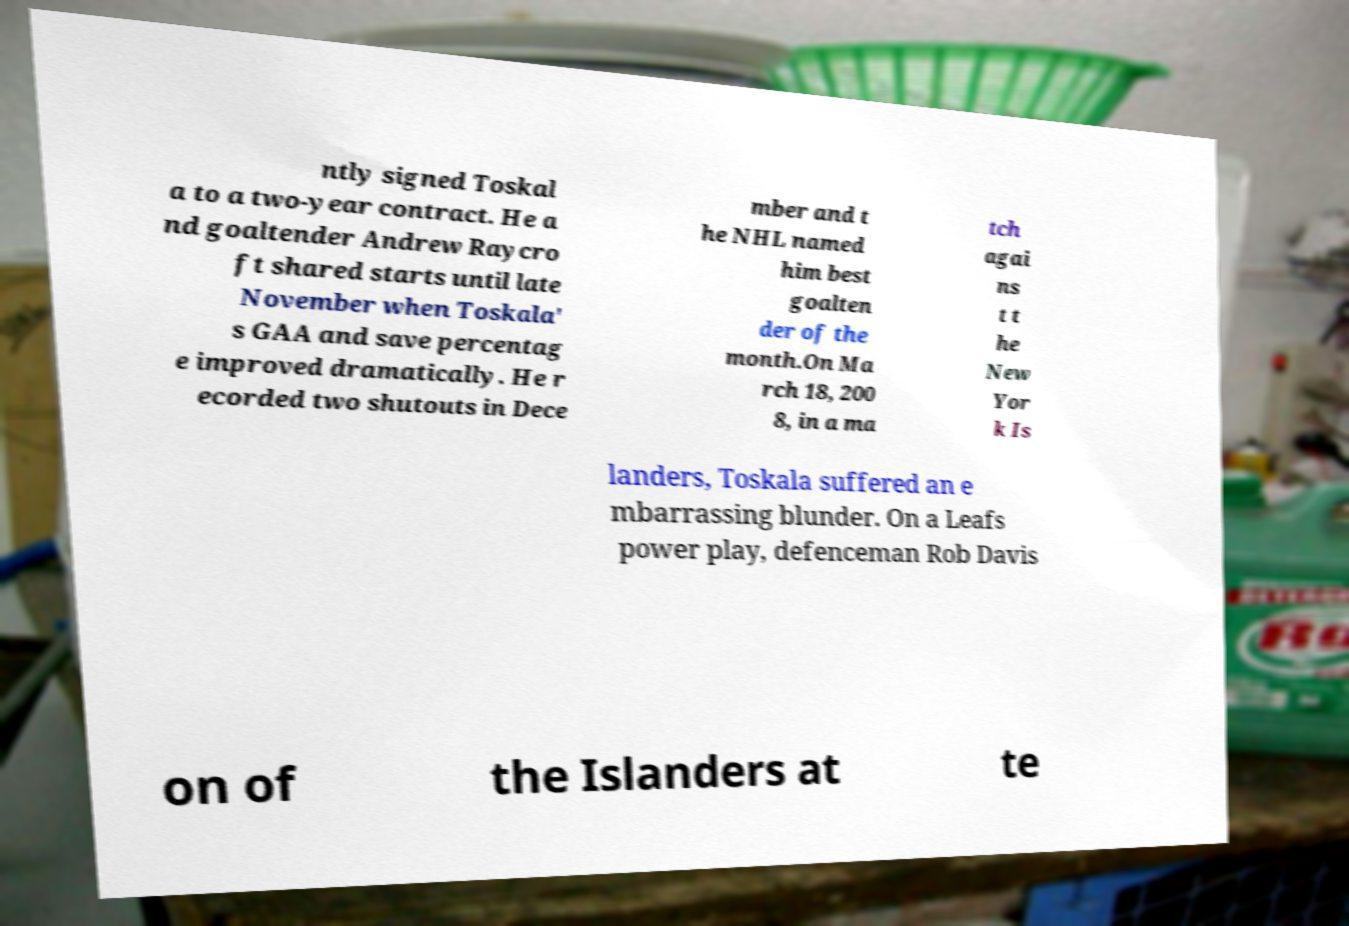Please identify and transcribe the text found in this image. ntly signed Toskal a to a two-year contract. He a nd goaltender Andrew Raycro ft shared starts until late November when Toskala' s GAA and save percentag e improved dramatically. He r ecorded two shutouts in Dece mber and t he NHL named him best goalten der of the month.On Ma rch 18, 200 8, in a ma tch agai ns t t he New Yor k Is landers, Toskala suffered an e mbarrassing blunder. On a Leafs power play, defenceman Rob Davis on of the Islanders at te 